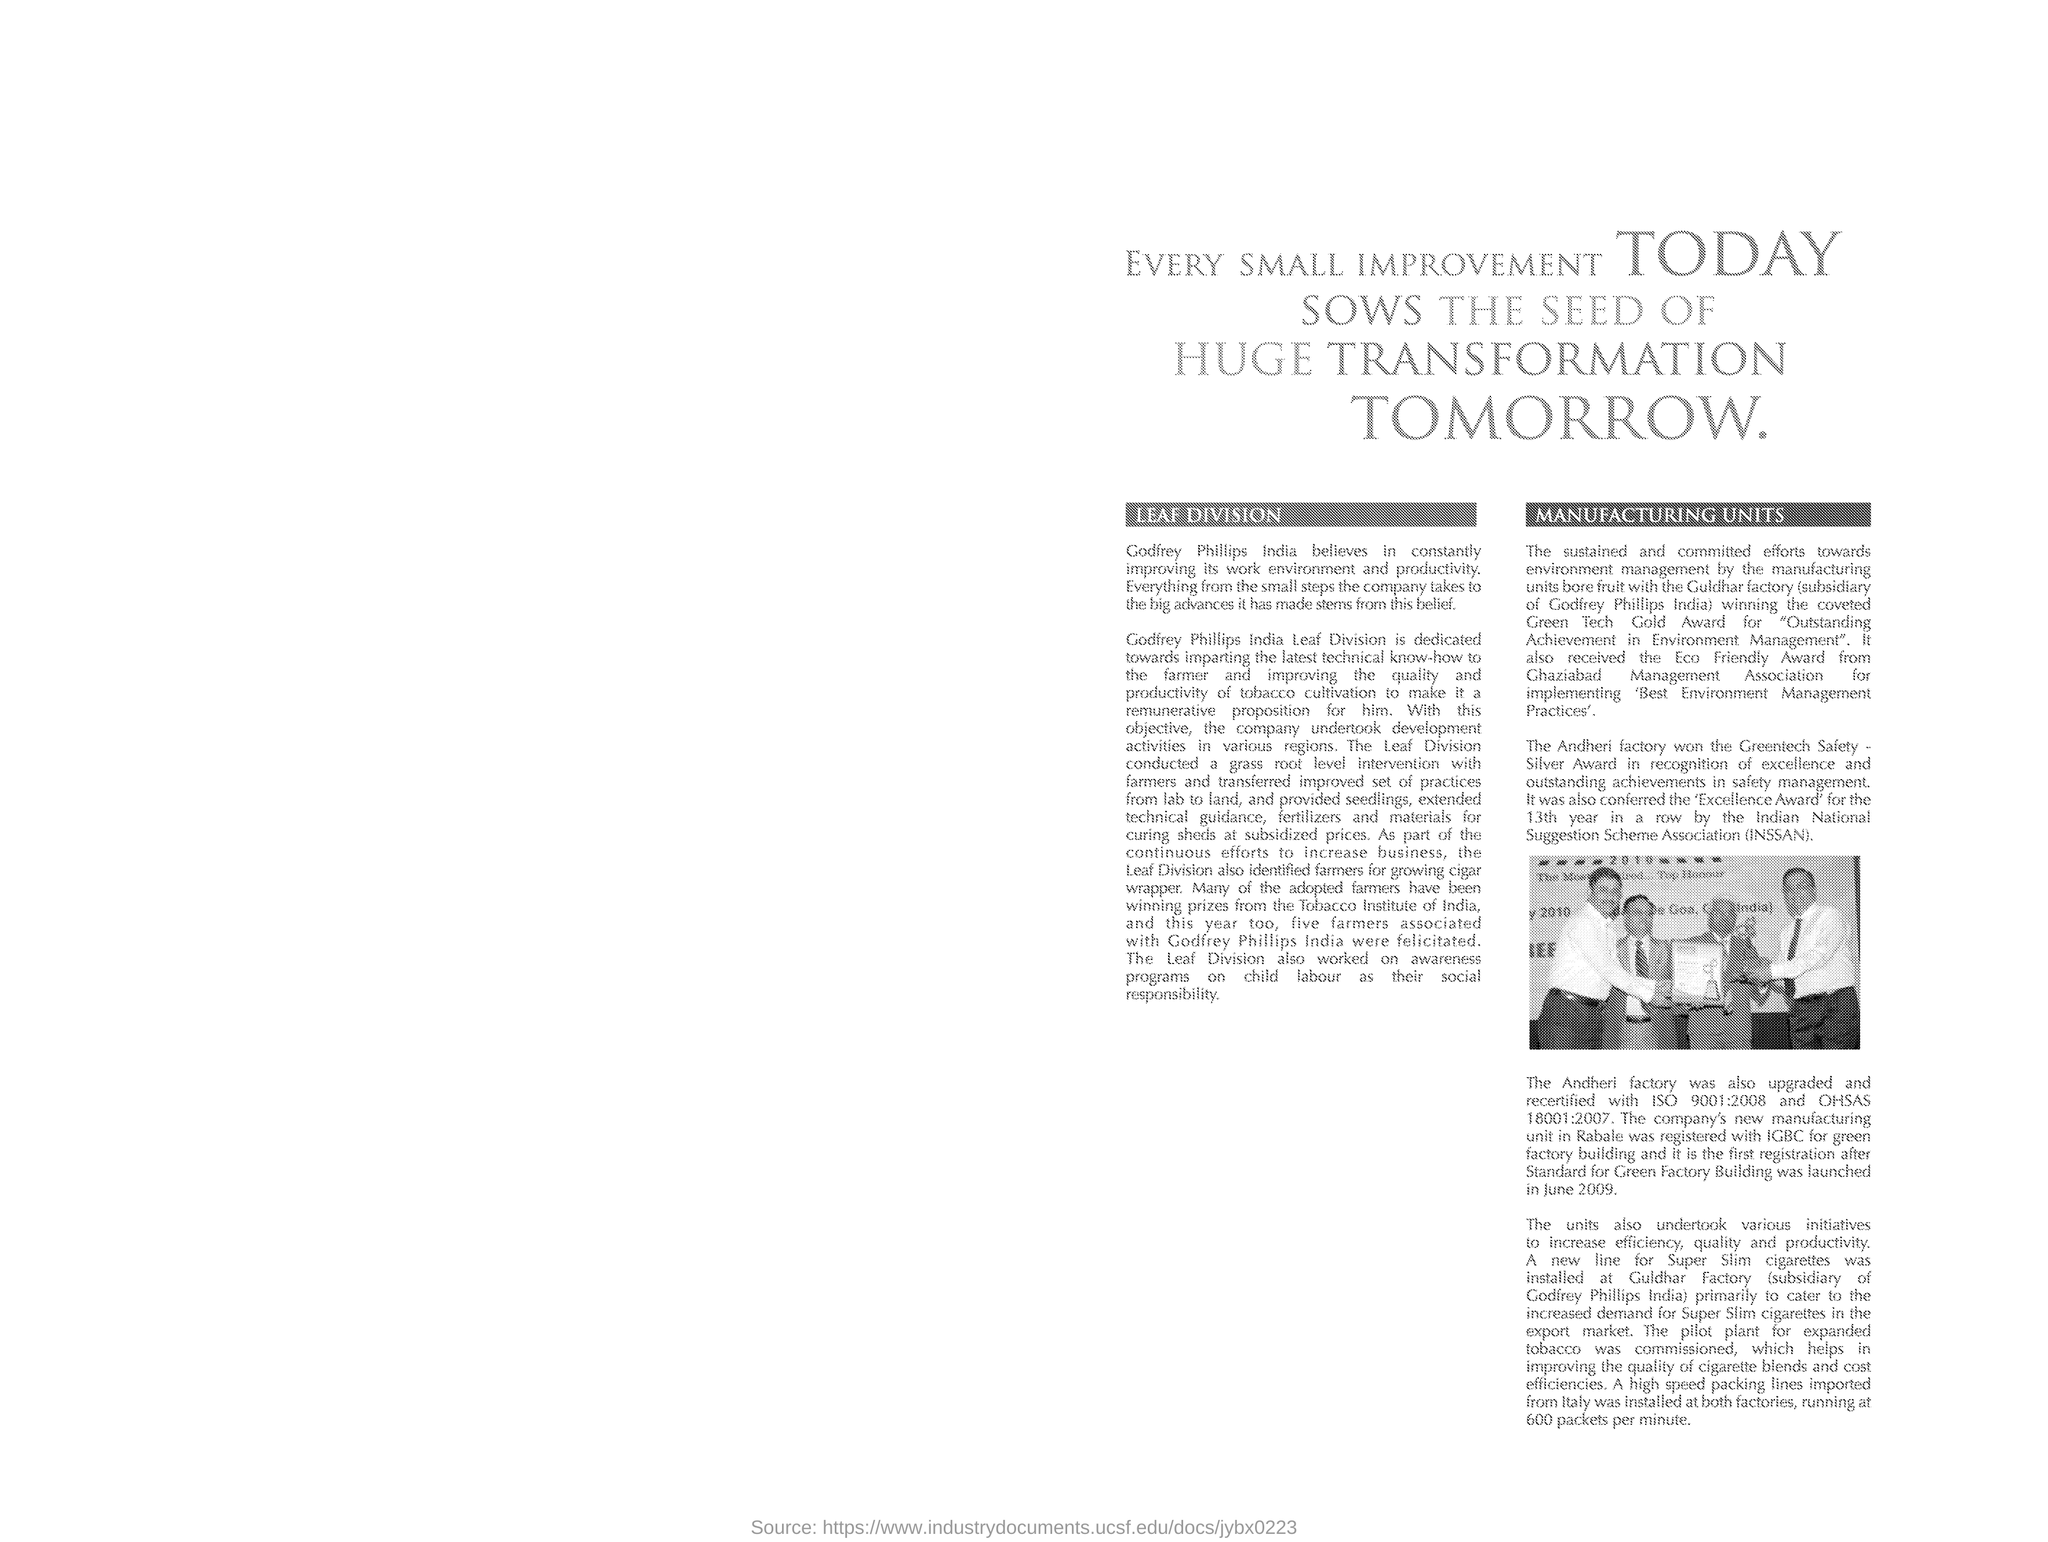What is the heading of the document?
Your answer should be very brief. Every small improvement today sows the seed of huge transformation tomorrow. What is the first side heading given?
Make the answer very short. Leaf division. What is the second side heading given?
Offer a very short reply. MANUFACTURING UNITS. Leaf Division identified farmers for growing what?
Give a very brief answer. Cigar wrapper. Which is mentioned as the "subsidiary of Godfrey Phillips India"?
Your answer should be very brief. Guldhar factory. Which award did Guldhar factory win?
Give a very brief answer. Green Tech Gold Award. "Green Tech Gold Award" is given for what achievement?
Provide a short and direct response. Outstanding achievement in environment management. What is the expansion of "INSSAN"?
Your answer should be compact. Indian national suggestion scheme association. Where is company's new manufacturing unit located?
Ensure brevity in your answer.  Rabale. 